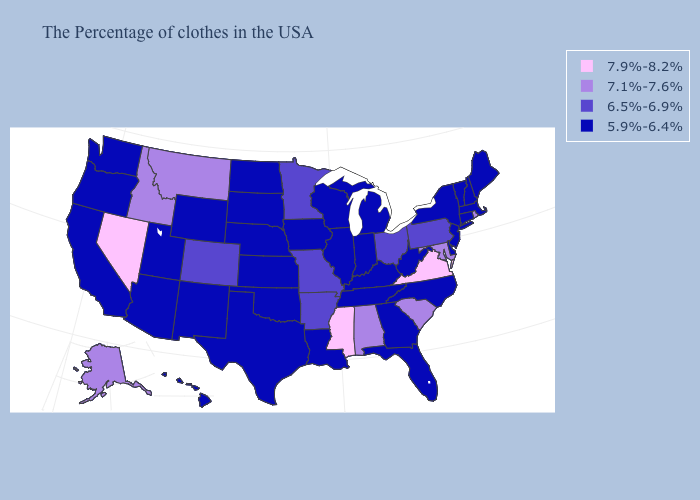What is the value of Montana?
Give a very brief answer. 7.1%-7.6%. Which states have the lowest value in the USA?
Be succinct. Maine, Massachusetts, New Hampshire, Vermont, Connecticut, New York, New Jersey, Delaware, North Carolina, West Virginia, Florida, Georgia, Michigan, Kentucky, Indiana, Tennessee, Wisconsin, Illinois, Louisiana, Iowa, Kansas, Nebraska, Oklahoma, Texas, South Dakota, North Dakota, Wyoming, New Mexico, Utah, Arizona, California, Washington, Oregon, Hawaii. What is the highest value in states that border California?
Answer briefly. 7.9%-8.2%. Does the map have missing data?
Be succinct. No. What is the lowest value in the South?
Be succinct. 5.9%-6.4%. What is the value of Iowa?
Answer briefly. 5.9%-6.4%. What is the highest value in states that border Rhode Island?
Concise answer only. 5.9%-6.4%. What is the lowest value in states that border Delaware?
Quick response, please. 5.9%-6.4%. Which states have the lowest value in the MidWest?
Be succinct. Michigan, Indiana, Wisconsin, Illinois, Iowa, Kansas, Nebraska, South Dakota, North Dakota. Does the first symbol in the legend represent the smallest category?
Be succinct. No. Which states have the lowest value in the USA?
Be succinct. Maine, Massachusetts, New Hampshire, Vermont, Connecticut, New York, New Jersey, Delaware, North Carolina, West Virginia, Florida, Georgia, Michigan, Kentucky, Indiana, Tennessee, Wisconsin, Illinois, Louisiana, Iowa, Kansas, Nebraska, Oklahoma, Texas, South Dakota, North Dakota, Wyoming, New Mexico, Utah, Arizona, California, Washington, Oregon, Hawaii. Does the first symbol in the legend represent the smallest category?
Answer briefly. No. Which states have the lowest value in the South?
Be succinct. Delaware, North Carolina, West Virginia, Florida, Georgia, Kentucky, Tennessee, Louisiana, Oklahoma, Texas. What is the lowest value in the MidWest?
Concise answer only. 5.9%-6.4%. Name the states that have a value in the range 6.5%-6.9%?
Short answer required. Pennsylvania, Ohio, Missouri, Arkansas, Minnesota, Colorado. 